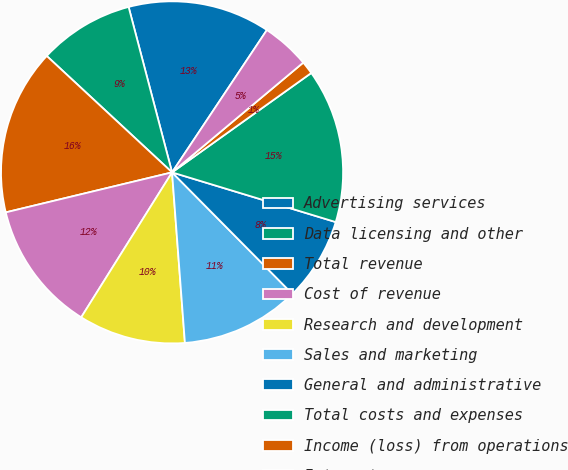<chart> <loc_0><loc_0><loc_500><loc_500><pie_chart><fcel>Advertising services<fcel>Data licensing and other<fcel>Total revenue<fcel>Cost of revenue<fcel>Research and development<fcel>Sales and marketing<fcel>General and administrative<fcel>Total costs and expenses<fcel>Income (loss) from operations<fcel>Interest expense<nl><fcel>13.44%<fcel>9.0%<fcel>15.67%<fcel>12.33%<fcel>10.11%<fcel>11.22%<fcel>7.89%<fcel>14.56%<fcel>1.22%<fcel>4.56%<nl></chart> 